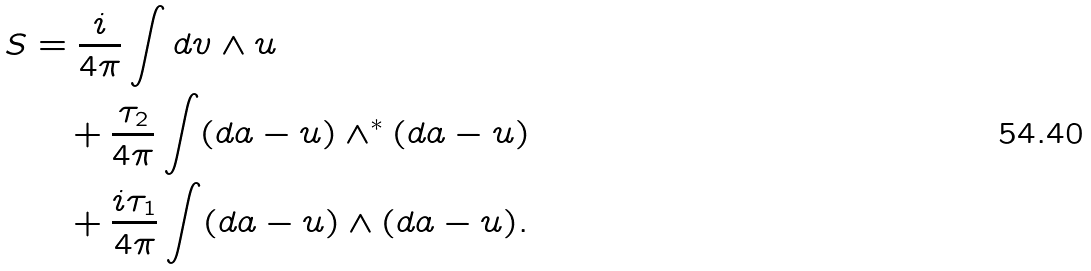<formula> <loc_0><loc_0><loc_500><loc_500>S & = \frac { i } { 4 \pi } \int d v \wedge u \\ & \quad + \frac { \tau _ { 2 } } { 4 \pi } \int ( d a - u ) \wedge ^ { * } ( d a - u ) \\ & \quad + \frac { i \tau _ { 1 } } { 4 \pi } \int ( d a - u ) \wedge ( d a - u ) .</formula> 